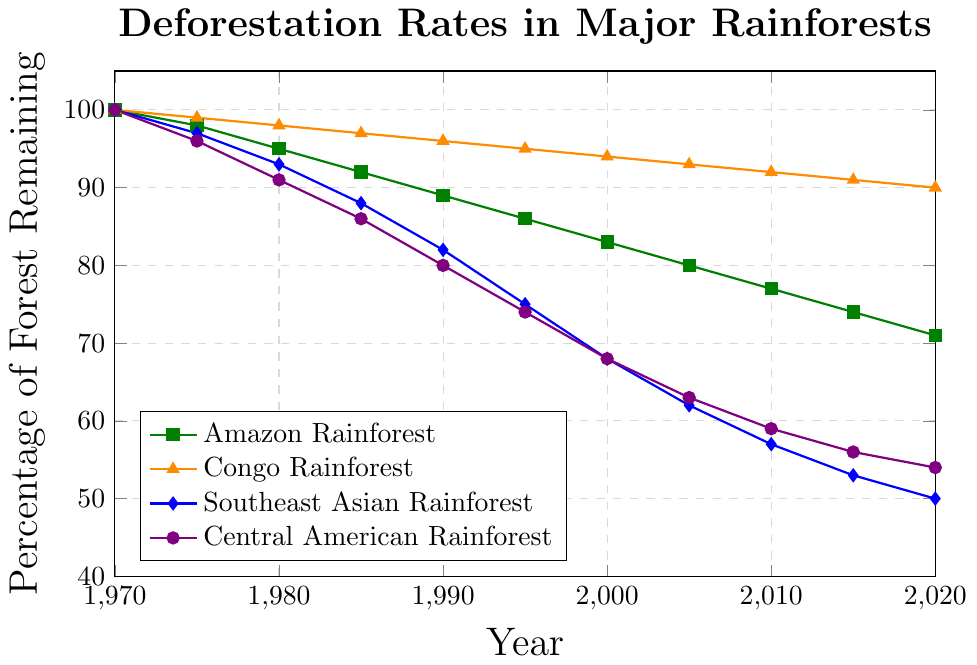What was the percentage of the Amazon Rainforest remaining in 1985? The plot shows a downward trend for the Amazon Rainforest, and looking at the 1985 data point, it is just above 90 percent.
Answer: 92% Which rainforest had the least percentage of forest remaining in 2020? Among the four rainforests, the Southeast Asian Rainforest's line is the lowest at the year 2020 on the x-axis.
Answer: Southeast Asian Rainforest What is the difference in the percentage of forest remaining between the Southeast Asian Rainforest and the Central American Rainforest in 2000? The Southeast Asian Rainforest has 68%, and the Central American Rainforest also has 68% in 2000. Subtracting these values gives a difference of 0%.
Answer: 0% Which rainforest experienced the greatest decrease in percentage from 1970 to 2020? By comparing the percentage points in 1970 and 2020 for each rainforest, the Southeast Asian Rainforest decreases from 100% to 50%, which is the largest drop of 50%.
Answer: Southeast Asian Rainforest In which year did the Amazon Rainforest's percentage drop below 80%? Inspecting the Amazon Rainforest's line, it first drops below 80% between 2000 and 2005, so in 2005 it was below 80%.
Answer: 2005 Compare the rates of decline for the Amazon Rainforest and the Congo Rainforest between 1990 and 2020. Which one is steeper? The Amazon dropped from 89% to 71%, a decline of 18%, while the Congo Rainforest dropped from 96% to 90%, a decline of 6%. The Amazon Rainforest's rate of decline is steeper.
Answer: Amazon Rainforest What is the average percentage of forest remaining for the Central American Rainforest from 1970 to 2020? Adding all percentages for the Central American Rainforest (100, 96, 91, 86, 80, 74, 68, 63, 59, 56, 54) results in 827, and dividing by 11 years yields approximately 75.2.
Answer: 75.2% How does the percentage of forest remaining in the Amazon Rainforest in 1990 compare to that in the Congo Rainforest in 2010? The Amazon Rainforest in 1990 is at 89%, and the Congo Rainforest in 2010 is at 92%, making the Congo Rainforest higher in 2010.
Answer: Congo Rainforest in 2010 Which rainforest shows a very gradual and consistent decline over the period from 1970 to 2020? The Congo Rainforest's line shows a gradual and consistent decline, with percentages slowly decreasing over time without sharp drops.
Answer: Congo Rainforest 